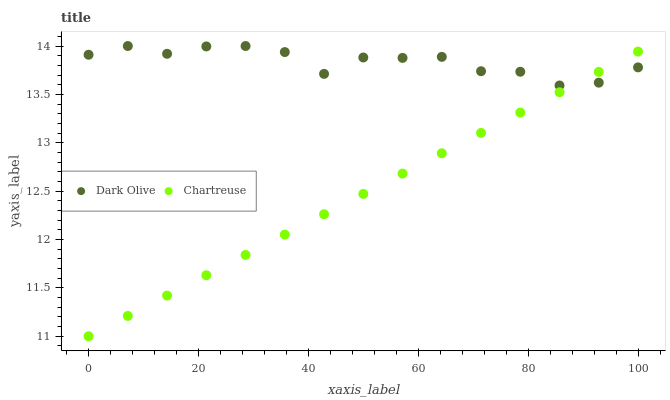Does Chartreuse have the minimum area under the curve?
Answer yes or no. Yes. Does Dark Olive have the maximum area under the curve?
Answer yes or no. Yes. Does Dark Olive have the minimum area under the curve?
Answer yes or no. No. Is Chartreuse the smoothest?
Answer yes or no. Yes. Is Dark Olive the roughest?
Answer yes or no. Yes. Is Dark Olive the smoothest?
Answer yes or no. No. Does Chartreuse have the lowest value?
Answer yes or no. Yes. Does Dark Olive have the lowest value?
Answer yes or no. No. Does Dark Olive have the highest value?
Answer yes or no. Yes. Does Dark Olive intersect Chartreuse?
Answer yes or no. Yes. Is Dark Olive less than Chartreuse?
Answer yes or no. No. Is Dark Olive greater than Chartreuse?
Answer yes or no. No. 